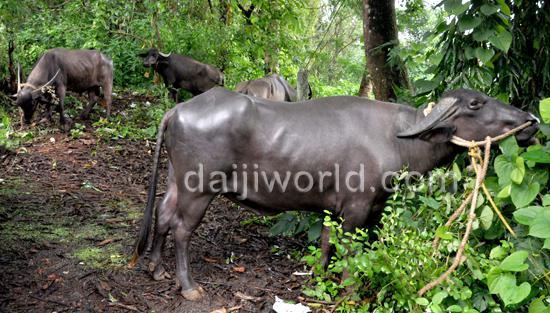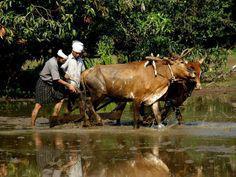The first image is the image on the left, the second image is the image on the right. Assess this claim about the two images: "Each image shows at least one man interacting with a team of two hitched oxen, and one image shows a man holding a stick behind oxen.". Correct or not? Answer yes or no. No. The first image is the image on the left, the second image is the image on the right. Given the left and right images, does the statement "In one of the images, water buffalos are standing in muddy water." hold true? Answer yes or no. Yes. 